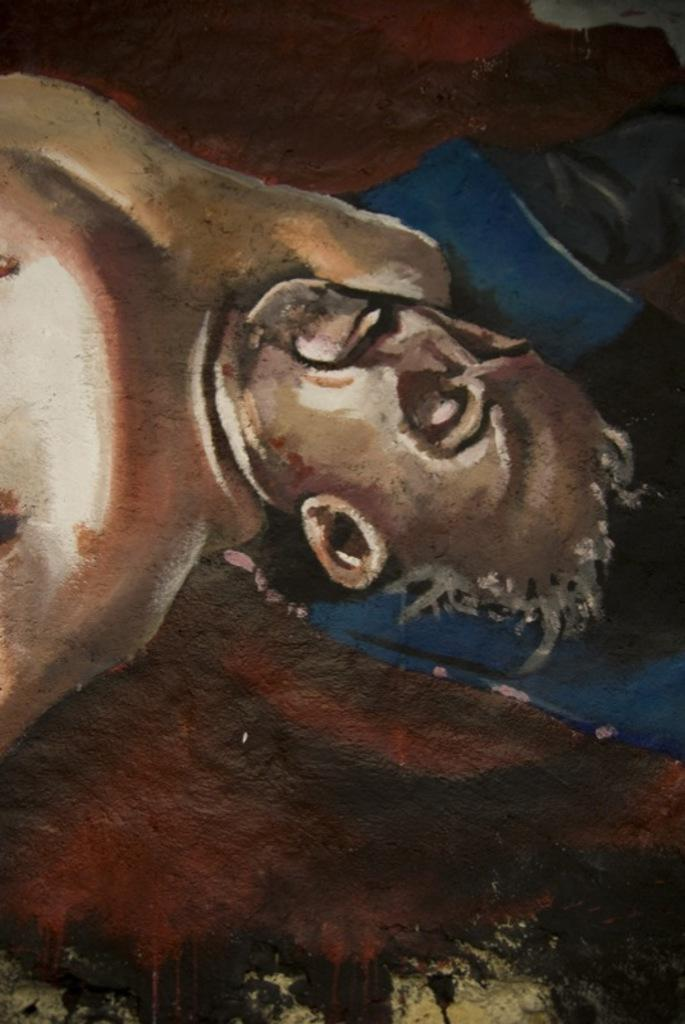What is the main subject of the image? There is a painting in the image. What is the painting depicting? The painting depicts a person. Are there any other elements in the painting besides the person? Yes, there are other objects present in the painting. What type of stick is the man holding in the painting? There is no man present in the painting, as it depicts a person. Additionally, there is no stick visible in the painting. 